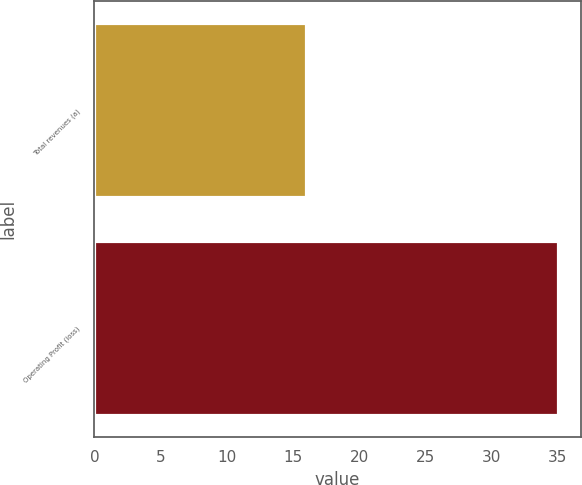<chart> <loc_0><loc_0><loc_500><loc_500><bar_chart><fcel>Total revenues (a)<fcel>Operating Profit (loss)<nl><fcel>16<fcel>35<nl></chart> 